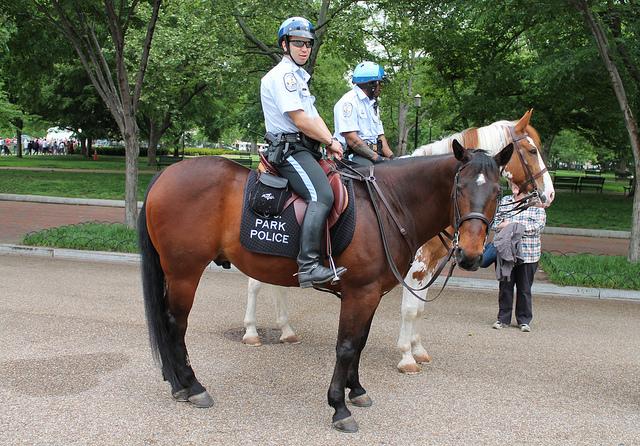What color, primarily, is the horse's vest?
Short answer required. Black. Are both officers looking at the camera?
Answer briefly. No. What kind of animal is this?
Concise answer only. Horse. Are these police officers?
Be succinct. Yes. What is on the man's head?
Answer briefly. Helmet. 